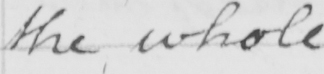Can you read and transcribe this handwriting? the whole 